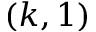Convert formula to latex. <formula><loc_0><loc_0><loc_500><loc_500>( k , 1 )</formula> 